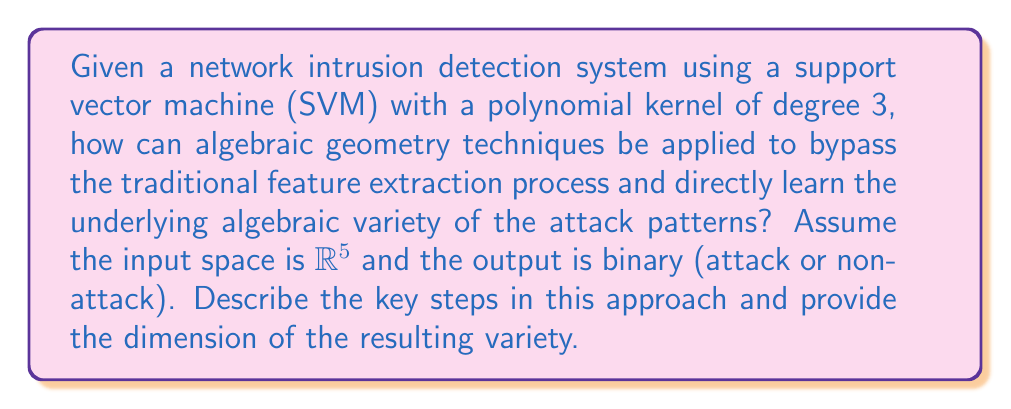Could you help me with this problem? 1. Traditional SVM with polynomial kernel of degree 3 uses the following decision function:
   $$f(x) = \text{sign}(\sum_{i=1}^n \alpha_i y_i (\langle x_i, x \rangle + 1)^3 + b)$$

2. Instead of using this kernel trick, we can directly model the algebraic variety of attack patterns:
   
   a) Consider all monomials of degree up to 3 in 5 variables:
      $$\{1, x_1, x_2, x_3, x_4, x_5, x_1^2, x_1x_2, ..., x_5^3\}$$
   
   b) There are $\binom{5+3}{3} = 56$ such monomials.

3. Map the input space to this 56-dimensional space using these monomials.

4. The attack patterns now form an algebraic variety in this 56-dimensional space.

5. Use techniques from algebraic geometry to learn this variety:
   a) Fit a system of polynomial equations to the data points.
   b) Use Gröbner basis algorithms to simplify and solve the system.

6. The dimension of the variety is the number of free parameters in the solution.

7. Assuming the variety is not the whole space and not just isolated points, its dimension is likely between 1 and 55.

8. A typical dimension might be around 10, representing a complex but not full-dimensional subspace of attack patterns.

This approach bypasses traditional feature engineering and kernel methods, directly learning the algebraic structure of attack patterns.
Answer: 10 